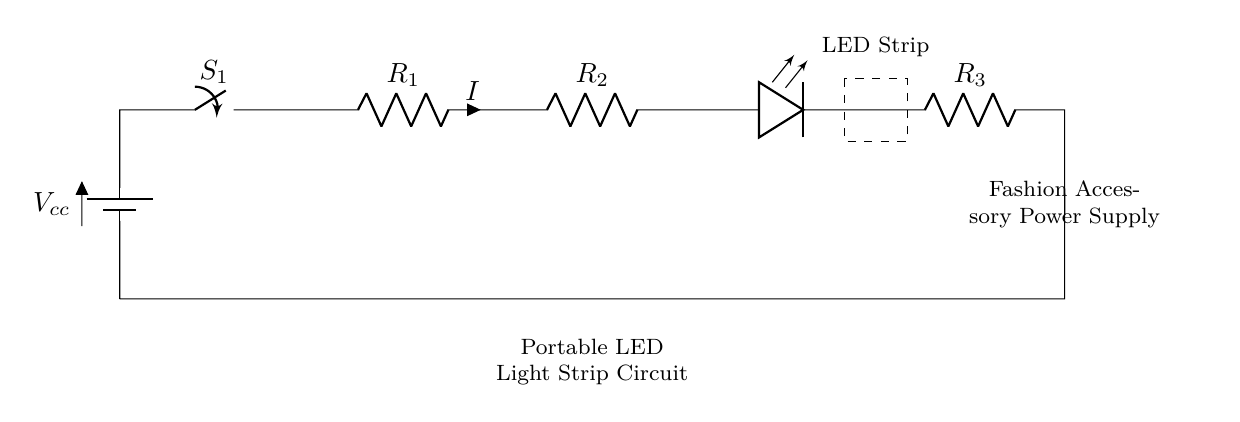What is the voltage source in this circuit? The circuit uses a battery labeled as Vcc, which supplies the voltage necessary to power the LED strip.
Answer: Vcc How many resistors are in the circuit? There are three resistors labeled R1, R2, and R3 in the diagram, connected in series with the other components.
Answer: 3 What component is located at the end of the circuit? The final component in the series circuit is an LED, which emits light when current flows through it.
Answer: LED What is the function of the switch in this circuit? The switch, labeled S1, is used to open or close the circuit, allowing or stopping the flow of current to the LED strip.
Answer: Open/Close What happens to the current if one resistor fails? If one resistor fails, the entire series circuit will be interrupted, causing all components to stop working as current cannot flow through a broken connection.
Answer: Stops Which component limits the current flowing to the LED? Resistor R3 is specifically used to limit the current flowing to the LED, protecting it from excessive current that could damage it.
Answer: R3 What type of circuit is represented here? The circuit depicted here is a series circuit since all components are connected end-to-end in a single path for the current to flow.
Answer: Series 